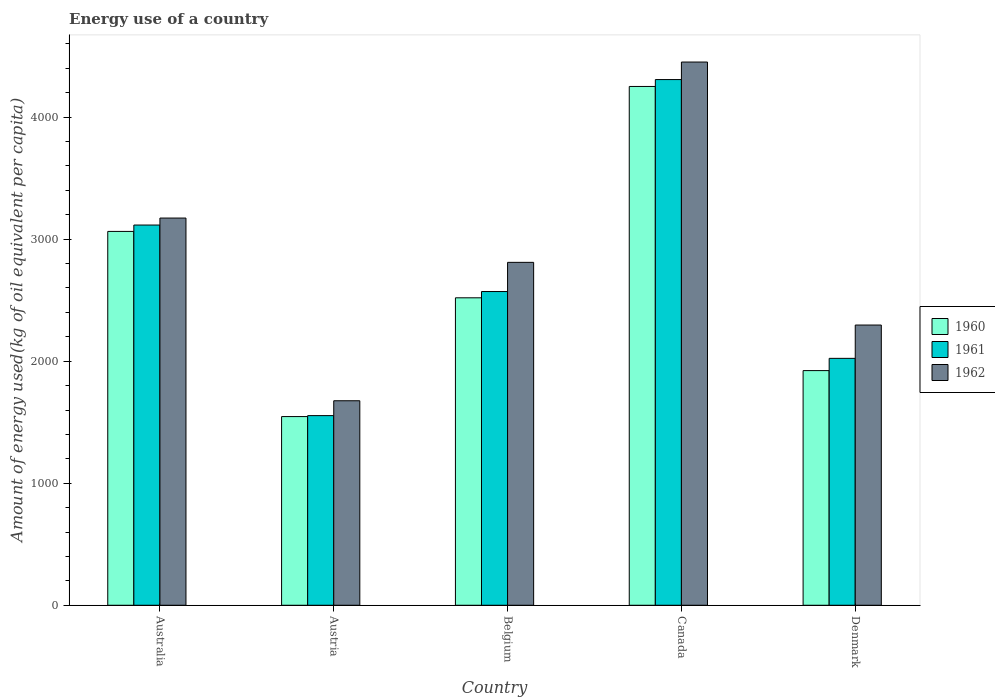How many groups of bars are there?
Provide a short and direct response. 5. Are the number of bars on each tick of the X-axis equal?
Provide a short and direct response. Yes. What is the label of the 2nd group of bars from the left?
Provide a succinct answer. Austria. What is the amount of energy used in in 1961 in Canada?
Your answer should be very brief. 4307.82. Across all countries, what is the maximum amount of energy used in in 1961?
Your answer should be compact. 4307.82. Across all countries, what is the minimum amount of energy used in in 1961?
Offer a terse response. 1554.03. What is the total amount of energy used in in 1961 in the graph?
Provide a succinct answer. 1.36e+04. What is the difference between the amount of energy used in in 1961 in Australia and that in Denmark?
Offer a very short reply. 1092.48. What is the difference between the amount of energy used in in 1961 in Australia and the amount of energy used in in 1962 in Denmark?
Provide a short and direct response. 819.5. What is the average amount of energy used in in 1961 per country?
Offer a terse response. 2714.35. What is the difference between the amount of energy used in of/in 1960 and amount of energy used in of/in 1961 in Belgium?
Make the answer very short. -51.32. What is the ratio of the amount of energy used in in 1960 in Australia to that in Denmark?
Your answer should be very brief. 1.59. Is the amount of energy used in in 1961 in Austria less than that in Denmark?
Provide a succinct answer. Yes. Is the difference between the amount of energy used in in 1960 in Belgium and Canada greater than the difference between the amount of energy used in in 1961 in Belgium and Canada?
Make the answer very short. Yes. What is the difference between the highest and the second highest amount of energy used in in 1960?
Give a very brief answer. -1731.94. What is the difference between the highest and the lowest amount of energy used in in 1962?
Ensure brevity in your answer.  2775.69. In how many countries, is the amount of energy used in in 1961 greater than the average amount of energy used in in 1961 taken over all countries?
Offer a very short reply. 2. What does the 3rd bar from the right in Austria represents?
Offer a very short reply. 1960. How many countries are there in the graph?
Keep it short and to the point. 5. What is the difference between two consecutive major ticks on the Y-axis?
Give a very brief answer. 1000. Are the values on the major ticks of Y-axis written in scientific E-notation?
Your response must be concise. No. Does the graph contain any zero values?
Offer a very short reply. No. How many legend labels are there?
Ensure brevity in your answer.  3. What is the title of the graph?
Offer a very short reply. Energy use of a country. What is the label or title of the X-axis?
Ensure brevity in your answer.  Country. What is the label or title of the Y-axis?
Provide a succinct answer. Amount of energy used(kg of oil equivalent per capita). What is the Amount of energy used(kg of oil equivalent per capita) in 1960 in Australia?
Give a very brief answer. 3063.55. What is the Amount of energy used(kg of oil equivalent per capita) in 1961 in Australia?
Your response must be concise. 3115.79. What is the Amount of energy used(kg of oil equivalent per capita) in 1962 in Australia?
Ensure brevity in your answer.  3172.97. What is the Amount of energy used(kg of oil equivalent per capita) in 1960 in Austria?
Your answer should be compact. 1546.26. What is the Amount of energy used(kg of oil equivalent per capita) in 1961 in Austria?
Offer a very short reply. 1554.03. What is the Amount of energy used(kg of oil equivalent per capita) in 1962 in Austria?
Ensure brevity in your answer.  1675.87. What is the Amount of energy used(kg of oil equivalent per capita) of 1960 in Belgium?
Keep it short and to the point. 2519.5. What is the Amount of energy used(kg of oil equivalent per capita) of 1961 in Belgium?
Your answer should be very brief. 2570.82. What is the Amount of energy used(kg of oil equivalent per capita) in 1962 in Belgium?
Your response must be concise. 2810.06. What is the Amount of energy used(kg of oil equivalent per capita) of 1960 in Canada?
Your response must be concise. 4251.44. What is the Amount of energy used(kg of oil equivalent per capita) in 1961 in Canada?
Your answer should be very brief. 4307.82. What is the Amount of energy used(kg of oil equivalent per capita) in 1962 in Canada?
Your answer should be very brief. 4451.56. What is the Amount of energy used(kg of oil equivalent per capita) in 1960 in Denmark?
Provide a succinct answer. 1922.97. What is the Amount of energy used(kg of oil equivalent per capita) of 1961 in Denmark?
Provide a succinct answer. 2023.31. What is the Amount of energy used(kg of oil equivalent per capita) of 1962 in Denmark?
Offer a terse response. 2296.29. Across all countries, what is the maximum Amount of energy used(kg of oil equivalent per capita) of 1960?
Make the answer very short. 4251.44. Across all countries, what is the maximum Amount of energy used(kg of oil equivalent per capita) of 1961?
Provide a succinct answer. 4307.82. Across all countries, what is the maximum Amount of energy used(kg of oil equivalent per capita) in 1962?
Your answer should be very brief. 4451.56. Across all countries, what is the minimum Amount of energy used(kg of oil equivalent per capita) in 1960?
Offer a very short reply. 1546.26. Across all countries, what is the minimum Amount of energy used(kg of oil equivalent per capita) in 1961?
Offer a very short reply. 1554.03. Across all countries, what is the minimum Amount of energy used(kg of oil equivalent per capita) of 1962?
Keep it short and to the point. 1675.87. What is the total Amount of energy used(kg of oil equivalent per capita) in 1960 in the graph?
Your answer should be very brief. 1.33e+04. What is the total Amount of energy used(kg of oil equivalent per capita) in 1961 in the graph?
Make the answer very short. 1.36e+04. What is the total Amount of energy used(kg of oil equivalent per capita) of 1962 in the graph?
Your answer should be very brief. 1.44e+04. What is the difference between the Amount of energy used(kg of oil equivalent per capita) in 1960 in Australia and that in Austria?
Provide a succinct answer. 1517.29. What is the difference between the Amount of energy used(kg of oil equivalent per capita) in 1961 in Australia and that in Austria?
Ensure brevity in your answer.  1561.75. What is the difference between the Amount of energy used(kg of oil equivalent per capita) of 1962 in Australia and that in Austria?
Ensure brevity in your answer.  1497.1. What is the difference between the Amount of energy used(kg of oil equivalent per capita) of 1960 in Australia and that in Belgium?
Your response must be concise. 544.06. What is the difference between the Amount of energy used(kg of oil equivalent per capita) of 1961 in Australia and that in Belgium?
Your answer should be compact. 544.97. What is the difference between the Amount of energy used(kg of oil equivalent per capita) in 1962 in Australia and that in Belgium?
Your answer should be compact. 362.91. What is the difference between the Amount of energy used(kg of oil equivalent per capita) in 1960 in Australia and that in Canada?
Give a very brief answer. -1187.88. What is the difference between the Amount of energy used(kg of oil equivalent per capita) of 1961 in Australia and that in Canada?
Ensure brevity in your answer.  -1192.03. What is the difference between the Amount of energy used(kg of oil equivalent per capita) in 1962 in Australia and that in Canada?
Your answer should be very brief. -1278.59. What is the difference between the Amount of energy used(kg of oil equivalent per capita) of 1960 in Australia and that in Denmark?
Give a very brief answer. 1140.58. What is the difference between the Amount of energy used(kg of oil equivalent per capita) in 1961 in Australia and that in Denmark?
Make the answer very short. 1092.48. What is the difference between the Amount of energy used(kg of oil equivalent per capita) in 1962 in Australia and that in Denmark?
Provide a succinct answer. 876.69. What is the difference between the Amount of energy used(kg of oil equivalent per capita) in 1960 in Austria and that in Belgium?
Offer a terse response. -973.24. What is the difference between the Amount of energy used(kg of oil equivalent per capita) of 1961 in Austria and that in Belgium?
Keep it short and to the point. -1016.78. What is the difference between the Amount of energy used(kg of oil equivalent per capita) of 1962 in Austria and that in Belgium?
Your answer should be compact. -1134.19. What is the difference between the Amount of energy used(kg of oil equivalent per capita) in 1960 in Austria and that in Canada?
Provide a short and direct response. -2705.17. What is the difference between the Amount of energy used(kg of oil equivalent per capita) of 1961 in Austria and that in Canada?
Provide a short and direct response. -2753.79. What is the difference between the Amount of energy used(kg of oil equivalent per capita) of 1962 in Austria and that in Canada?
Provide a succinct answer. -2775.69. What is the difference between the Amount of energy used(kg of oil equivalent per capita) of 1960 in Austria and that in Denmark?
Make the answer very short. -376.71. What is the difference between the Amount of energy used(kg of oil equivalent per capita) in 1961 in Austria and that in Denmark?
Offer a terse response. -469.27. What is the difference between the Amount of energy used(kg of oil equivalent per capita) in 1962 in Austria and that in Denmark?
Give a very brief answer. -620.42. What is the difference between the Amount of energy used(kg of oil equivalent per capita) of 1960 in Belgium and that in Canada?
Your answer should be very brief. -1731.94. What is the difference between the Amount of energy used(kg of oil equivalent per capita) in 1961 in Belgium and that in Canada?
Your response must be concise. -1737.01. What is the difference between the Amount of energy used(kg of oil equivalent per capita) in 1962 in Belgium and that in Canada?
Keep it short and to the point. -1641.5. What is the difference between the Amount of energy used(kg of oil equivalent per capita) in 1960 in Belgium and that in Denmark?
Your answer should be compact. 596.52. What is the difference between the Amount of energy used(kg of oil equivalent per capita) of 1961 in Belgium and that in Denmark?
Your answer should be compact. 547.51. What is the difference between the Amount of energy used(kg of oil equivalent per capita) in 1962 in Belgium and that in Denmark?
Ensure brevity in your answer.  513.77. What is the difference between the Amount of energy used(kg of oil equivalent per capita) in 1960 in Canada and that in Denmark?
Your answer should be compact. 2328.46. What is the difference between the Amount of energy used(kg of oil equivalent per capita) of 1961 in Canada and that in Denmark?
Your answer should be very brief. 2284.51. What is the difference between the Amount of energy used(kg of oil equivalent per capita) of 1962 in Canada and that in Denmark?
Offer a terse response. 2155.27. What is the difference between the Amount of energy used(kg of oil equivalent per capita) in 1960 in Australia and the Amount of energy used(kg of oil equivalent per capita) in 1961 in Austria?
Offer a very short reply. 1509.52. What is the difference between the Amount of energy used(kg of oil equivalent per capita) of 1960 in Australia and the Amount of energy used(kg of oil equivalent per capita) of 1962 in Austria?
Make the answer very short. 1387.68. What is the difference between the Amount of energy used(kg of oil equivalent per capita) of 1961 in Australia and the Amount of energy used(kg of oil equivalent per capita) of 1962 in Austria?
Offer a very short reply. 1439.91. What is the difference between the Amount of energy used(kg of oil equivalent per capita) of 1960 in Australia and the Amount of energy used(kg of oil equivalent per capita) of 1961 in Belgium?
Your response must be concise. 492.74. What is the difference between the Amount of energy used(kg of oil equivalent per capita) of 1960 in Australia and the Amount of energy used(kg of oil equivalent per capita) of 1962 in Belgium?
Make the answer very short. 253.49. What is the difference between the Amount of energy used(kg of oil equivalent per capita) of 1961 in Australia and the Amount of energy used(kg of oil equivalent per capita) of 1962 in Belgium?
Provide a succinct answer. 305.73. What is the difference between the Amount of energy used(kg of oil equivalent per capita) in 1960 in Australia and the Amount of energy used(kg of oil equivalent per capita) in 1961 in Canada?
Your answer should be very brief. -1244.27. What is the difference between the Amount of energy used(kg of oil equivalent per capita) of 1960 in Australia and the Amount of energy used(kg of oil equivalent per capita) of 1962 in Canada?
Offer a very short reply. -1388.01. What is the difference between the Amount of energy used(kg of oil equivalent per capita) of 1961 in Australia and the Amount of energy used(kg of oil equivalent per capita) of 1962 in Canada?
Keep it short and to the point. -1335.77. What is the difference between the Amount of energy used(kg of oil equivalent per capita) of 1960 in Australia and the Amount of energy used(kg of oil equivalent per capita) of 1961 in Denmark?
Keep it short and to the point. 1040.25. What is the difference between the Amount of energy used(kg of oil equivalent per capita) of 1960 in Australia and the Amount of energy used(kg of oil equivalent per capita) of 1962 in Denmark?
Ensure brevity in your answer.  767.26. What is the difference between the Amount of energy used(kg of oil equivalent per capita) in 1961 in Australia and the Amount of energy used(kg of oil equivalent per capita) in 1962 in Denmark?
Provide a short and direct response. 819.5. What is the difference between the Amount of energy used(kg of oil equivalent per capita) of 1960 in Austria and the Amount of energy used(kg of oil equivalent per capita) of 1961 in Belgium?
Provide a succinct answer. -1024.55. What is the difference between the Amount of energy used(kg of oil equivalent per capita) in 1960 in Austria and the Amount of energy used(kg of oil equivalent per capita) in 1962 in Belgium?
Make the answer very short. -1263.8. What is the difference between the Amount of energy used(kg of oil equivalent per capita) in 1961 in Austria and the Amount of energy used(kg of oil equivalent per capita) in 1962 in Belgium?
Your answer should be compact. -1256.03. What is the difference between the Amount of energy used(kg of oil equivalent per capita) of 1960 in Austria and the Amount of energy used(kg of oil equivalent per capita) of 1961 in Canada?
Keep it short and to the point. -2761.56. What is the difference between the Amount of energy used(kg of oil equivalent per capita) in 1960 in Austria and the Amount of energy used(kg of oil equivalent per capita) in 1962 in Canada?
Offer a terse response. -2905.3. What is the difference between the Amount of energy used(kg of oil equivalent per capita) of 1961 in Austria and the Amount of energy used(kg of oil equivalent per capita) of 1962 in Canada?
Ensure brevity in your answer.  -2897.53. What is the difference between the Amount of energy used(kg of oil equivalent per capita) in 1960 in Austria and the Amount of energy used(kg of oil equivalent per capita) in 1961 in Denmark?
Give a very brief answer. -477.05. What is the difference between the Amount of energy used(kg of oil equivalent per capita) in 1960 in Austria and the Amount of energy used(kg of oil equivalent per capita) in 1962 in Denmark?
Keep it short and to the point. -750.03. What is the difference between the Amount of energy used(kg of oil equivalent per capita) in 1961 in Austria and the Amount of energy used(kg of oil equivalent per capita) in 1962 in Denmark?
Keep it short and to the point. -742.25. What is the difference between the Amount of energy used(kg of oil equivalent per capita) of 1960 in Belgium and the Amount of energy used(kg of oil equivalent per capita) of 1961 in Canada?
Give a very brief answer. -1788.32. What is the difference between the Amount of energy used(kg of oil equivalent per capita) in 1960 in Belgium and the Amount of energy used(kg of oil equivalent per capita) in 1962 in Canada?
Make the answer very short. -1932.06. What is the difference between the Amount of energy used(kg of oil equivalent per capita) of 1961 in Belgium and the Amount of energy used(kg of oil equivalent per capita) of 1962 in Canada?
Provide a short and direct response. -1880.74. What is the difference between the Amount of energy used(kg of oil equivalent per capita) in 1960 in Belgium and the Amount of energy used(kg of oil equivalent per capita) in 1961 in Denmark?
Make the answer very short. 496.19. What is the difference between the Amount of energy used(kg of oil equivalent per capita) of 1960 in Belgium and the Amount of energy used(kg of oil equivalent per capita) of 1962 in Denmark?
Make the answer very short. 223.21. What is the difference between the Amount of energy used(kg of oil equivalent per capita) of 1961 in Belgium and the Amount of energy used(kg of oil equivalent per capita) of 1962 in Denmark?
Give a very brief answer. 274.53. What is the difference between the Amount of energy used(kg of oil equivalent per capita) of 1960 in Canada and the Amount of energy used(kg of oil equivalent per capita) of 1961 in Denmark?
Your answer should be compact. 2228.13. What is the difference between the Amount of energy used(kg of oil equivalent per capita) in 1960 in Canada and the Amount of energy used(kg of oil equivalent per capita) in 1962 in Denmark?
Keep it short and to the point. 1955.15. What is the difference between the Amount of energy used(kg of oil equivalent per capita) of 1961 in Canada and the Amount of energy used(kg of oil equivalent per capita) of 1962 in Denmark?
Ensure brevity in your answer.  2011.53. What is the average Amount of energy used(kg of oil equivalent per capita) in 1960 per country?
Make the answer very short. 2660.74. What is the average Amount of energy used(kg of oil equivalent per capita) in 1961 per country?
Make the answer very short. 2714.35. What is the average Amount of energy used(kg of oil equivalent per capita) of 1962 per country?
Provide a succinct answer. 2881.35. What is the difference between the Amount of energy used(kg of oil equivalent per capita) in 1960 and Amount of energy used(kg of oil equivalent per capita) in 1961 in Australia?
Your answer should be compact. -52.23. What is the difference between the Amount of energy used(kg of oil equivalent per capita) in 1960 and Amount of energy used(kg of oil equivalent per capita) in 1962 in Australia?
Your answer should be very brief. -109.42. What is the difference between the Amount of energy used(kg of oil equivalent per capita) of 1961 and Amount of energy used(kg of oil equivalent per capita) of 1962 in Australia?
Provide a succinct answer. -57.19. What is the difference between the Amount of energy used(kg of oil equivalent per capita) of 1960 and Amount of energy used(kg of oil equivalent per capita) of 1961 in Austria?
Offer a very short reply. -7.77. What is the difference between the Amount of energy used(kg of oil equivalent per capita) of 1960 and Amount of energy used(kg of oil equivalent per capita) of 1962 in Austria?
Keep it short and to the point. -129.61. What is the difference between the Amount of energy used(kg of oil equivalent per capita) of 1961 and Amount of energy used(kg of oil equivalent per capita) of 1962 in Austria?
Offer a terse response. -121.84. What is the difference between the Amount of energy used(kg of oil equivalent per capita) in 1960 and Amount of energy used(kg of oil equivalent per capita) in 1961 in Belgium?
Offer a terse response. -51.32. What is the difference between the Amount of energy used(kg of oil equivalent per capita) in 1960 and Amount of energy used(kg of oil equivalent per capita) in 1962 in Belgium?
Give a very brief answer. -290.56. What is the difference between the Amount of energy used(kg of oil equivalent per capita) in 1961 and Amount of energy used(kg of oil equivalent per capita) in 1962 in Belgium?
Give a very brief answer. -239.25. What is the difference between the Amount of energy used(kg of oil equivalent per capita) of 1960 and Amount of energy used(kg of oil equivalent per capita) of 1961 in Canada?
Provide a succinct answer. -56.38. What is the difference between the Amount of energy used(kg of oil equivalent per capita) in 1960 and Amount of energy used(kg of oil equivalent per capita) in 1962 in Canada?
Offer a terse response. -200.12. What is the difference between the Amount of energy used(kg of oil equivalent per capita) in 1961 and Amount of energy used(kg of oil equivalent per capita) in 1962 in Canada?
Keep it short and to the point. -143.74. What is the difference between the Amount of energy used(kg of oil equivalent per capita) in 1960 and Amount of energy used(kg of oil equivalent per capita) in 1961 in Denmark?
Give a very brief answer. -100.33. What is the difference between the Amount of energy used(kg of oil equivalent per capita) of 1960 and Amount of energy used(kg of oil equivalent per capita) of 1962 in Denmark?
Your response must be concise. -373.32. What is the difference between the Amount of energy used(kg of oil equivalent per capita) of 1961 and Amount of energy used(kg of oil equivalent per capita) of 1962 in Denmark?
Make the answer very short. -272.98. What is the ratio of the Amount of energy used(kg of oil equivalent per capita) in 1960 in Australia to that in Austria?
Make the answer very short. 1.98. What is the ratio of the Amount of energy used(kg of oil equivalent per capita) of 1961 in Australia to that in Austria?
Your response must be concise. 2. What is the ratio of the Amount of energy used(kg of oil equivalent per capita) in 1962 in Australia to that in Austria?
Provide a short and direct response. 1.89. What is the ratio of the Amount of energy used(kg of oil equivalent per capita) of 1960 in Australia to that in Belgium?
Offer a terse response. 1.22. What is the ratio of the Amount of energy used(kg of oil equivalent per capita) of 1961 in Australia to that in Belgium?
Provide a short and direct response. 1.21. What is the ratio of the Amount of energy used(kg of oil equivalent per capita) in 1962 in Australia to that in Belgium?
Provide a succinct answer. 1.13. What is the ratio of the Amount of energy used(kg of oil equivalent per capita) in 1960 in Australia to that in Canada?
Provide a short and direct response. 0.72. What is the ratio of the Amount of energy used(kg of oil equivalent per capita) of 1961 in Australia to that in Canada?
Provide a short and direct response. 0.72. What is the ratio of the Amount of energy used(kg of oil equivalent per capita) in 1962 in Australia to that in Canada?
Your answer should be compact. 0.71. What is the ratio of the Amount of energy used(kg of oil equivalent per capita) of 1960 in Australia to that in Denmark?
Keep it short and to the point. 1.59. What is the ratio of the Amount of energy used(kg of oil equivalent per capita) of 1961 in Australia to that in Denmark?
Ensure brevity in your answer.  1.54. What is the ratio of the Amount of energy used(kg of oil equivalent per capita) in 1962 in Australia to that in Denmark?
Provide a succinct answer. 1.38. What is the ratio of the Amount of energy used(kg of oil equivalent per capita) in 1960 in Austria to that in Belgium?
Offer a terse response. 0.61. What is the ratio of the Amount of energy used(kg of oil equivalent per capita) of 1961 in Austria to that in Belgium?
Ensure brevity in your answer.  0.6. What is the ratio of the Amount of energy used(kg of oil equivalent per capita) of 1962 in Austria to that in Belgium?
Your answer should be very brief. 0.6. What is the ratio of the Amount of energy used(kg of oil equivalent per capita) of 1960 in Austria to that in Canada?
Offer a terse response. 0.36. What is the ratio of the Amount of energy used(kg of oil equivalent per capita) of 1961 in Austria to that in Canada?
Your answer should be very brief. 0.36. What is the ratio of the Amount of energy used(kg of oil equivalent per capita) in 1962 in Austria to that in Canada?
Your answer should be compact. 0.38. What is the ratio of the Amount of energy used(kg of oil equivalent per capita) of 1960 in Austria to that in Denmark?
Offer a terse response. 0.8. What is the ratio of the Amount of energy used(kg of oil equivalent per capita) of 1961 in Austria to that in Denmark?
Ensure brevity in your answer.  0.77. What is the ratio of the Amount of energy used(kg of oil equivalent per capita) of 1962 in Austria to that in Denmark?
Your answer should be compact. 0.73. What is the ratio of the Amount of energy used(kg of oil equivalent per capita) of 1960 in Belgium to that in Canada?
Ensure brevity in your answer.  0.59. What is the ratio of the Amount of energy used(kg of oil equivalent per capita) of 1961 in Belgium to that in Canada?
Keep it short and to the point. 0.6. What is the ratio of the Amount of energy used(kg of oil equivalent per capita) in 1962 in Belgium to that in Canada?
Your response must be concise. 0.63. What is the ratio of the Amount of energy used(kg of oil equivalent per capita) of 1960 in Belgium to that in Denmark?
Provide a short and direct response. 1.31. What is the ratio of the Amount of energy used(kg of oil equivalent per capita) of 1961 in Belgium to that in Denmark?
Offer a very short reply. 1.27. What is the ratio of the Amount of energy used(kg of oil equivalent per capita) of 1962 in Belgium to that in Denmark?
Offer a terse response. 1.22. What is the ratio of the Amount of energy used(kg of oil equivalent per capita) in 1960 in Canada to that in Denmark?
Offer a terse response. 2.21. What is the ratio of the Amount of energy used(kg of oil equivalent per capita) in 1961 in Canada to that in Denmark?
Provide a short and direct response. 2.13. What is the ratio of the Amount of energy used(kg of oil equivalent per capita) in 1962 in Canada to that in Denmark?
Make the answer very short. 1.94. What is the difference between the highest and the second highest Amount of energy used(kg of oil equivalent per capita) of 1960?
Your response must be concise. 1187.88. What is the difference between the highest and the second highest Amount of energy used(kg of oil equivalent per capita) of 1961?
Your answer should be compact. 1192.03. What is the difference between the highest and the second highest Amount of energy used(kg of oil equivalent per capita) in 1962?
Provide a succinct answer. 1278.59. What is the difference between the highest and the lowest Amount of energy used(kg of oil equivalent per capita) in 1960?
Ensure brevity in your answer.  2705.17. What is the difference between the highest and the lowest Amount of energy used(kg of oil equivalent per capita) of 1961?
Your response must be concise. 2753.79. What is the difference between the highest and the lowest Amount of energy used(kg of oil equivalent per capita) in 1962?
Keep it short and to the point. 2775.69. 